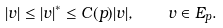Convert formula to latex. <formula><loc_0><loc_0><loc_500><loc_500>| v | \leq | v | ^ { * } \leq C ( p ) | v | , \quad v \in E _ { p } .</formula> 